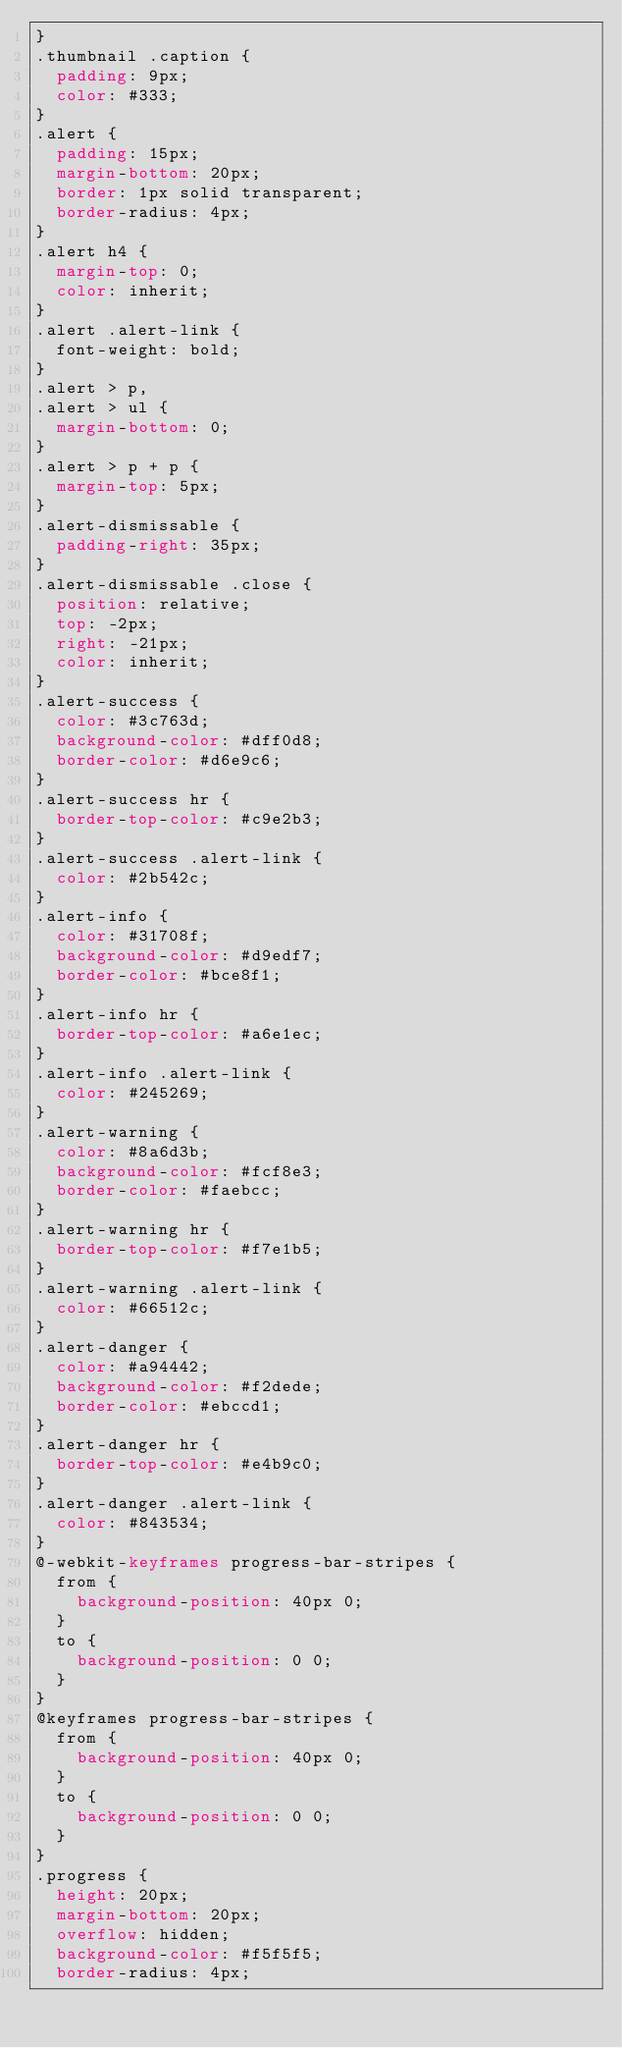<code> <loc_0><loc_0><loc_500><loc_500><_CSS_>}
.thumbnail .caption {
  padding: 9px;
  color: #333;
}
.alert {
  padding: 15px;
  margin-bottom: 20px;
  border: 1px solid transparent;
  border-radius: 4px;
}
.alert h4 {
  margin-top: 0;
  color: inherit;
}
.alert .alert-link {
  font-weight: bold;
}
.alert > p,
.alert > ul {
  margin-bottom: 0;
}
.alert > p + p {
  margin-top: 5px;
}
.alert-dismissable {
  padding-right: 35px;
}
.alert-dismissable .close {
  position: relative;
  top: -2px;
  right: -21px;
  color: inherit;
}
.alert-success {
  color: #3c763d;
  background-color: #dff0d8;
  border-color: #d6e9c6;
}
.alert-success hr {
  border-top-color: #c9e2b3;
}
.alert-success .alert-link {
  color: #2b542c;
}
.alert-info {
  color: #31708f;
  background-color: #d9edf7;
  border-color: #bce8f1;
}
.alert-info hr {
  border-top-color: #a6e1ec;
}
.alert-info .alert-link {
  color: #245269;
}
.alert-warning {
  color: #8a6d3b;
  background-color: #fcf8e3;
  border-color: #faebcc;
}
.alert-warning hr {
  border-top-color: #f7e1b5;
}
.alert-warning .alert-link {
  color: #66512c;
}
.alert-danger {
  color: #a94442;
  background-color: #f2dede;
  border-color: #ebccd1;
}
.alert-danger hr {
  border-top-color: #e4b9c0;
}
.alert-danger .alert-link {
  color: #843534;
}
@-webkit-keyframes progress-bar-stripes {
  from {
    background-position: 40px 0;
  }
  to {
    background-position: 0 0;
  }
}
@keyframes progress-bar-stripes {
  from {
    background-position: 40px 0;
  }
  to {
    background-position: 0 0;
  }
}
.progress {
  height: 20px;
  margin-bottom: 20px;
  overflow: hidden;
  background-color: #f5f5f5;
  border-radius: 4px;</code> 